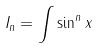Convert formula to latex. <formula><loc_0><loc_0><loc_500><loc_500>I _ { n } = \int \sin ^ { n } x</formula> 